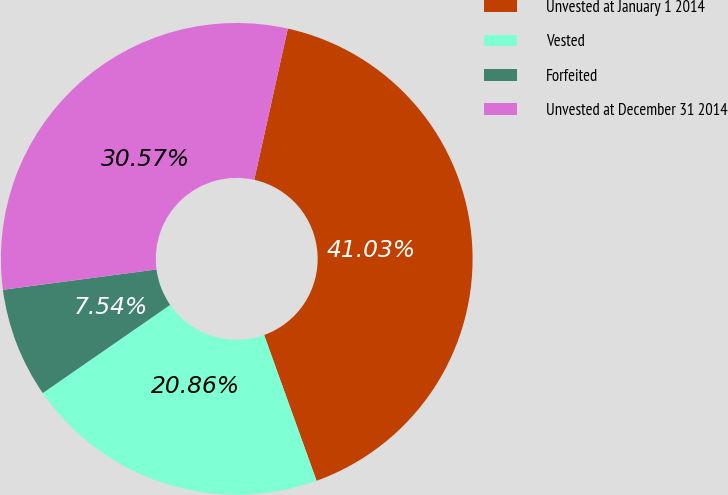Convert chart to OTSL. <chart><loc_0><loc_0><loc_500><loc_500><pie_chart><fcel>Unvested at January 1 2014<fcel>Vested<fcel>Forfeited<fcel>Unvested at December 31 2014<nl><fcel>41.03%<fcel>20.86%<fcel>7.54%<fcel>30.57%<nl></chart> 